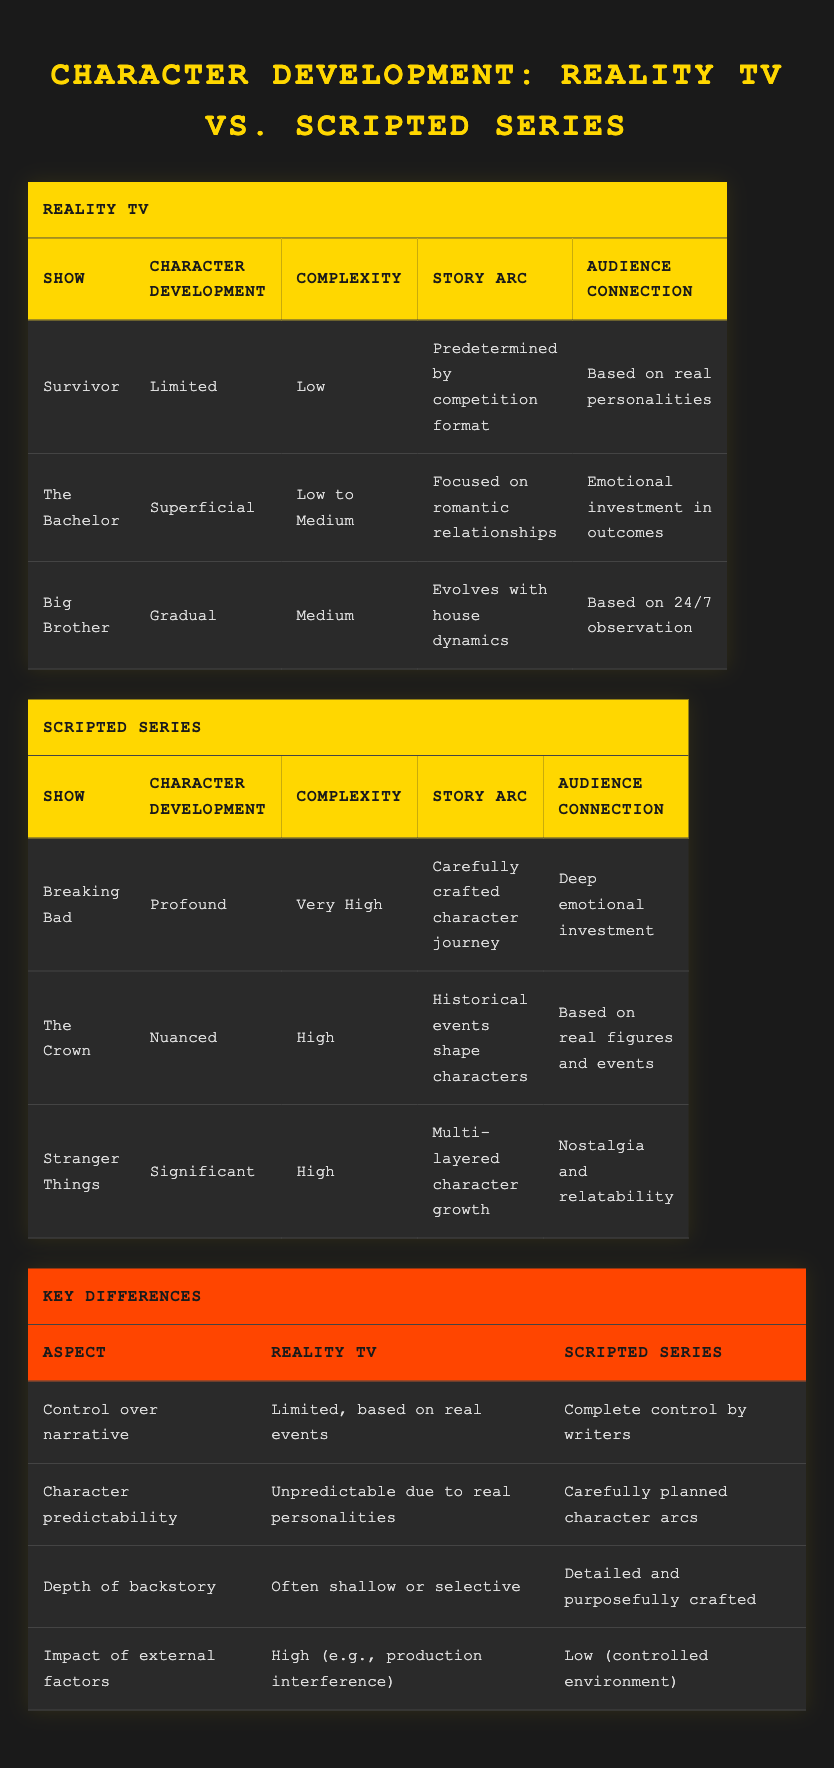What is the character development level of "The Bachelor"? In the table under the Reality TV section, "The Bachelor" is listed with "Superficial" as its character development level.
Answer: Superficial Which scripted series has the highest complexity rating? Looking at the Scripted Series table, "Breaking Bad" has a complexity rating of "Very High," which is the highest among the listed shows.
Answer: Breaking Bad Do reality TV shows generally have greater character complexity than scripted series? By examining the complexity ratings in both sections, reality TV shows have low to medium complexity, while scripted series range from high to very high, indicating that scripted series generally have greater character complexity.
Answer: No What are the story arcs of "Survivor" and "Breaking Bad"? In the Reality TV table, "Survivor" has a story arc that is "Predetermined by competition format," while in the Scripted Series table, "Breaking Bad" features a "Carefully crafted character journey."
Answer: Predetermined by competition format; Carefully crafted character journey Considering the aspects, how does character predictability differ between reality TV and scripted series? The Key Differences table shows that character predictability in reality TV is "Unpredictable due to real personalities," while in scripted series, it is "Carefully planned character arcs." This illustrates a notable difference in predictability.
Answer: Reality TV is unpredictable; Scripted series is planned What is the depth of backstory for "Stranger Things" and "Big Brother"? Referring to the Character Development Complexity data, "Stranger Things" has a detailed backstory as part of its "Significant" character development, while "Big Brother’s" backstory is often considered "shallow or selective." Comparing these notes shows the substantial difference in backstory depth.
Answer: Detailed; Shallow Which show has an audience connection based on real personalities in reality TV? The table specifies that "Survivor" has an audience connection "Based on real personalities," making it a clear answer.
Answer: Survivor How do external factors impact the character development process in reality TV compared to scripted series? The Key Differences table indicates that reality TV has a "High" impact from external factors like production interference, whereas scripted series have a "Low" impact due to controlled environments. This information shows a significant contrast.
Answer: High for reality TV; Low for scripted series 